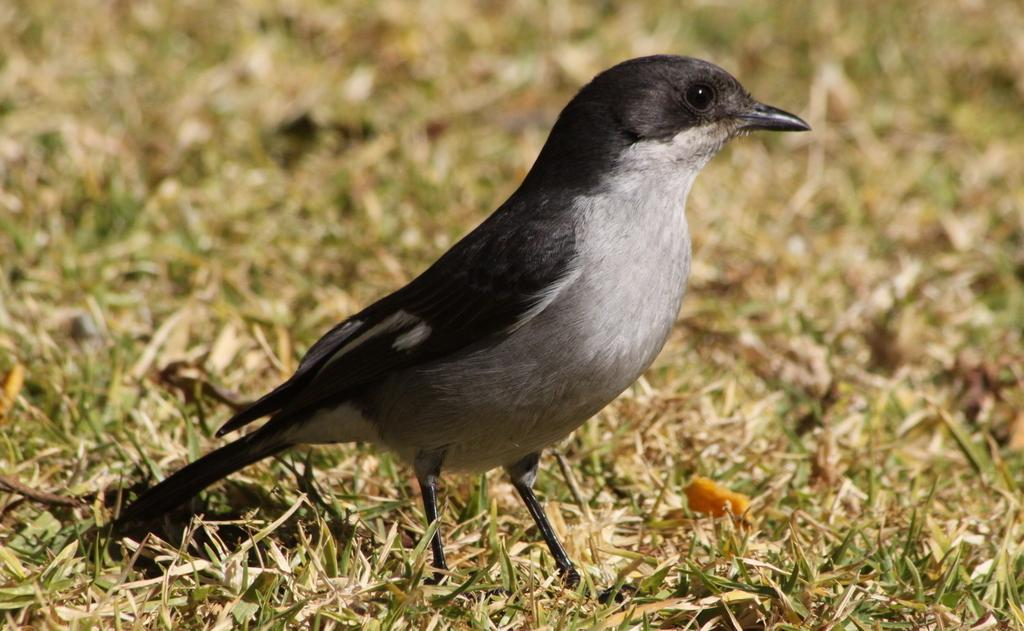What type of animal can be seen in the image? There is a bird in the image. What type of vegetation is visible in the image? There is grass visible in the image. What type of flower is the bird using to attack the ticket in the image? There is no flower, bird attack, or ticket present in the image. 